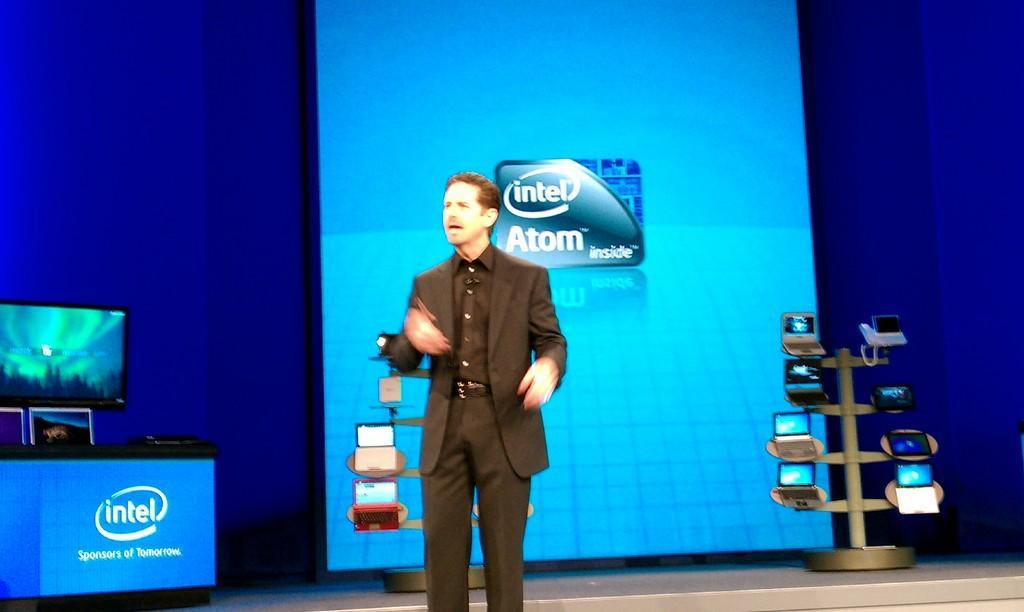Describe this image in one or two sentences. In the foreground I can see a person is standing on the stage, table, boards and a metal stand on which some laptops are there. In the background I can see a screen and a system. This image is taken may be on the stage. 